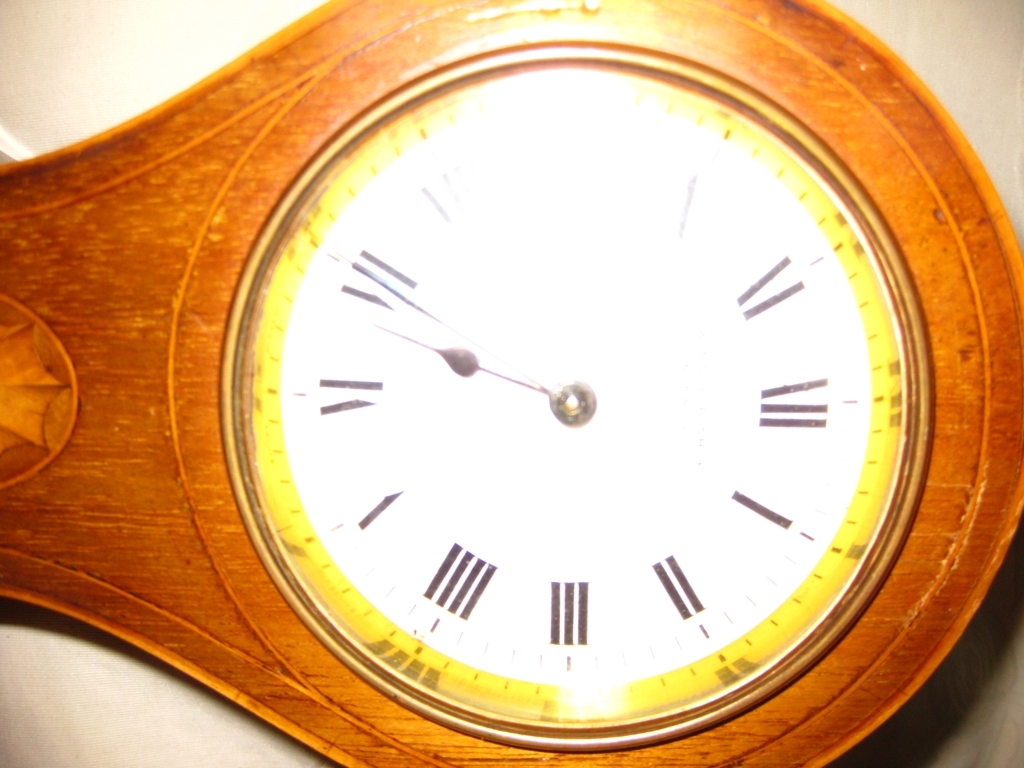What maintenance does a clock like this typically require? A clock of this style would likely require routine maintenance to ensure accurate timekeeping. This could include winding if it's a mechanical clock, battery replacement if it's quartz, and occasional cleaning of the clock face and casing to preserve its appearance and functionality. The wood may also need to be conditioned to prevent drying out. 